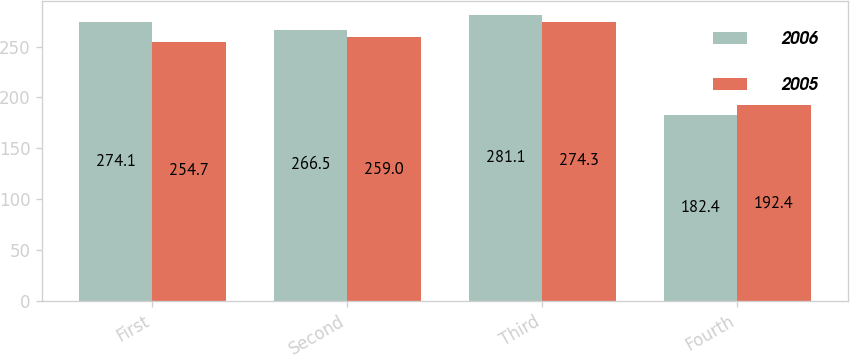Convert chart to OTSL. <chart><loc_0><loc_0><loc_500><loc_500><stacked_bar_chart><ecel><fcel>First<fcel>Second<fcel>Third<fcel>Fourth<nl><fcel>2006<fcel>274.1<fcel>266.5<fcel>281.1<fcel>182.4<nl><fcel>2005<fcel>254.7<fcel>259<fcel>274.3<fcel>192.4<nl></chart> 